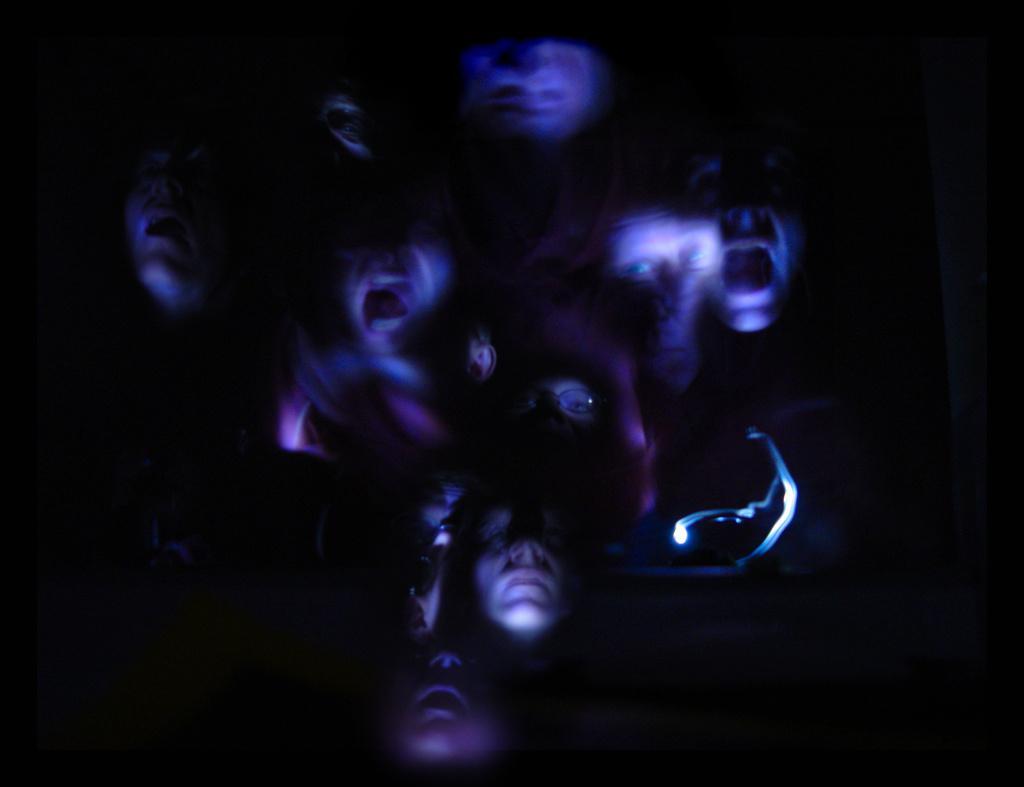In one or two sentences, can you explain what this image depicts? This is an edited picture. In the middle of the image faces of people are visible. 